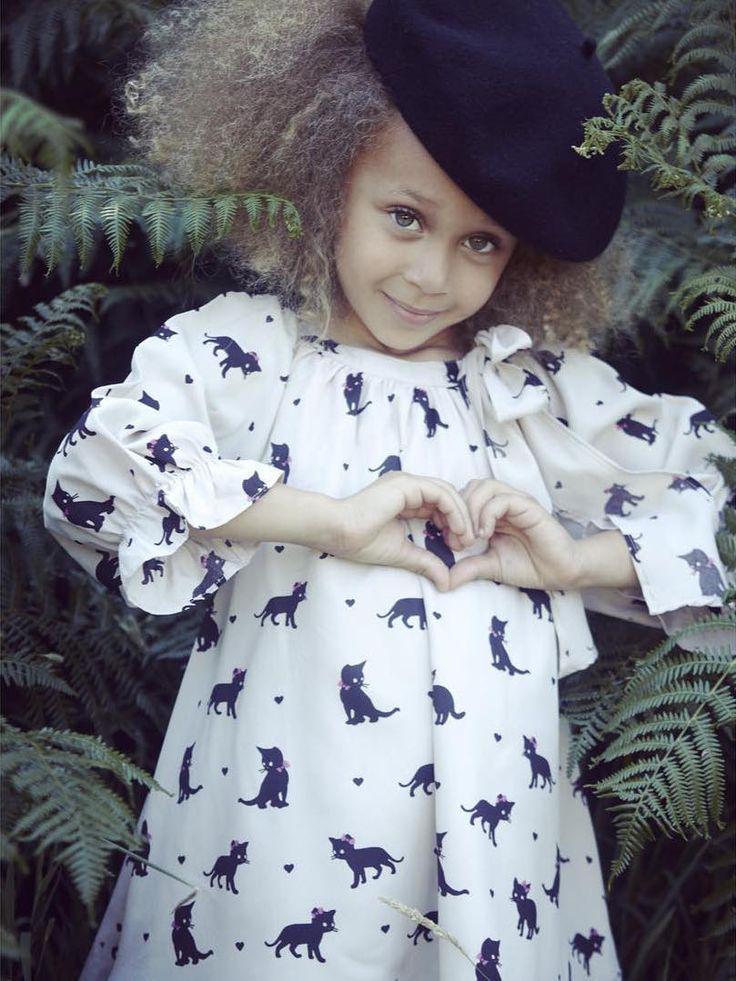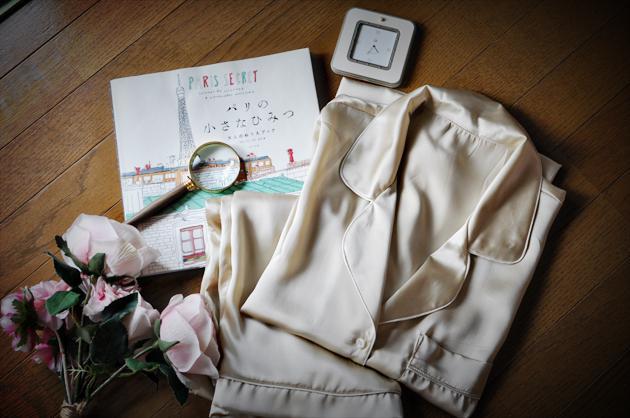The first image is the image on the left, the second image is the image on the right. Given the left and right images, does the statement "One image shows sleepwear displayed flat on a surface, instead of modeled by a person." hold true? Answer yes or no. Yes. The first image is the image on the left, the second image is the image on the right. Evaluate the accuracy of this statement regarding the images: "A plant stands in the corner behind and to the left of a woman standing with hands in her pockets.". Is it true? Answer yes or no. No. 